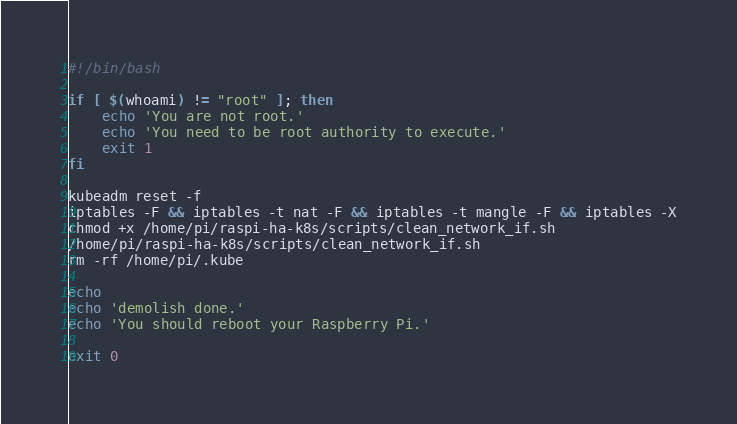Convert code to text. <code><loc_0><loc_0><loc_500><loc_500><_Bash_>#!/bin/bash

if [ $(whoami) != "root" ]; then
    echo 'You are not root.'
    echo 'You need to be root authority to execute.'
    exit 1
fi

kubeadm reset -f
iptables -F && iptables -t nat -F && iptables -t mangle -F && iptables -X
chmod +x /home/pi/raspi-ha-k8s/scripts/clean_network_if.sh
/home/pi/raspi-ha-k8s/scripts/clean_network_if.sh
rm -rf /home/pi/.kube

echo
echo 'demolish done.'
echo 'You should reboot your Raspberry Pi.'

exit 0
</code> 